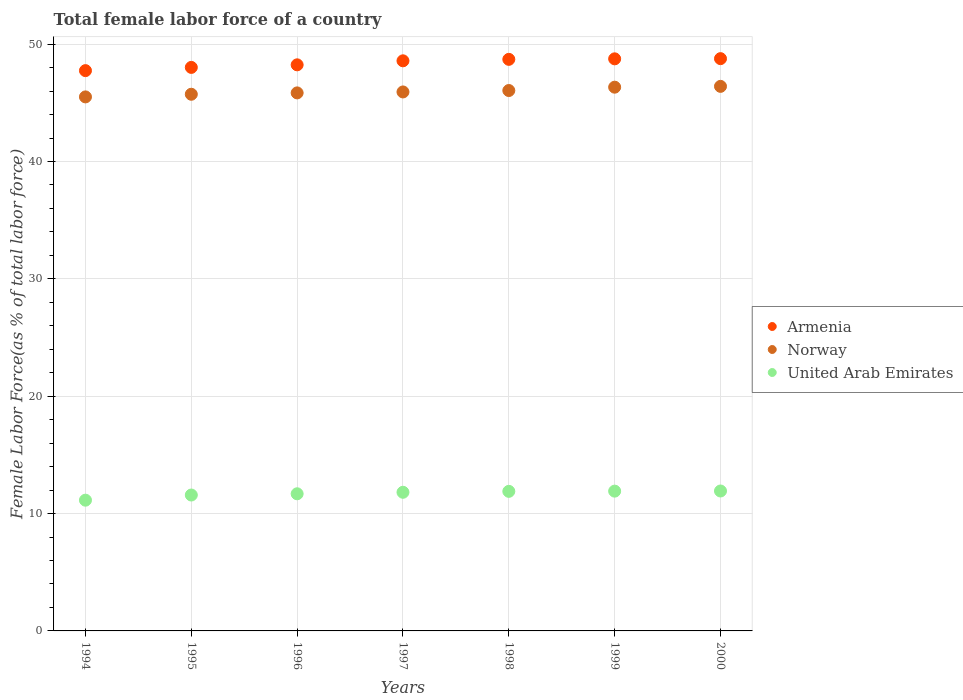How many different coloured dotlines are there?
Your answer should be very brief. 3. Is the number of dotlines equal to the number of legend labels?
Your response must be concise. Yes. What is the percentage of female labor force in Armenia in 1998?
Ensure brevity in your answer.  48.7. Across all years, what is the maximum percentage of female labor force in United Arab Emirates?
Your answer should be very brief. 11.92. Across all years, what is the minimum percentage of female labor force in United Arab Emirates?
Offer a terse response. 11.14. In which year was the percentage of female labor force in Norway maximum?
Provide a succinct answer. 2000. In which year was the percentage of female labor force in United Arab Emirates minimum?
Offer a terse response. 1994. What is the total percentage of female labor force in Armenia in the graph?
Ensure brevity in your answer.  338.8. What is the difference between the percentage of female labor force in Norway in 1996 and that in 1999?
Make the answer very short. -0.49. What is the difference between the percentage of female labor force in United Arab Emirates in 1998 and the percentage of female labor force in Armenia in 1996?
Your answer should be compact. -36.35. What is the average percentage of female labor force in United Arab Emirates per year?
Your answer should be compact. 11.71. In the year 1999, what is the difference between the percentage of female labor force in Armenia and percentage of female labor force in United Arab Emirates?
Give a very brief answer. 36.84. What is the ratio of the percentage of female labor force in Norway in 1995 to that in 1998?
Keep it short and to the point. 0.99. Is the difference between the percentage of female labor force in Armenia in 1998 and 1999 greater than the difference between the percentage of female labor force in United Arab Emirates in 1998 and 1999?
Ensure brevity in your answer.  No. What is the difference between the highest and the second highest percentage of female labor force in Norway?
Make the answer very short. 0.07. What is the difference between the highest and the lowest percentage of female labor force in United Arab Emirates?
Your answer should be very brief. 0.78. Is the percentage of female labor force in Norway strictly greater than the percentage of female labor force in Armenia over the years?
Provide a succinct answer. No. Is the percentage of female labor force in United Arab Emirates strictly less than the percentage of female labor force in Armenia over the years?
Offer a terse response. Yes. How many years are there in the graph?
Your response must be concise. 7. Are the values on the major ticks of Y-axis written in scientific E-notation?
Offer a terse response. No. How many legend labels are there?
Your answer should be compact. 3. What is the title of the graph?
Ensure brevity in your answer.  Total female labor force of a country. Does "Burkina Faso" appear as one of the legend labels in the graph?
Your answer should be very brief. No. What is the label or title of the X-axis?
Offer a very short reply. Years. What is the label or title of the Y-axis?
Ensure brevity in your answer.  Female Labor Force(as % of total labor force). What is the Female Labor Force(as % of total labor force) in Armenia in 1994?
Give a very brief answer. 47.74. What is the Female Labor Force(as % of total labor force) of Norway in 1994?
Your answer should be very brief. 45.5. What is the Female Labor Force(as % of total labor force) of United Arab Emirates in 1994?
Make the answer very short. 11.14. What is the Female Labor Force(as % of total labor force) in Armenia in 1995?
Ensure brevity in your answer.  48.02. What is the Female Labor Force(as % of total labor force) in Norway in 1995?
Give a very brief answer. 45.73. What is the Female Labor Force(as % of total labor force) in United Arab Emirates in 1995?
Provide a succinct answer. 11.58. What is the Female Labor Force(as % of total labor force) in Armenia in 1996?
Your response must be concise. 48.24. What is the Female Labor Force(as % of total labor force) of Norway in 1996?
Give a very brief answer. 45.85. What is the Female Labor Force(as % of total labor force) of United Arab Emirates in 1996?
Your response must be concise. 11.69. What is the Female Labor Force(as % of total labor force) in Armenia in 1997?
Give a very brief answer. 48.58. What is the Female Labor Force(as % of total labor force) in Norway in 1997?
Give a very brief answer. 45.93. What is the Female Labor Force(as % of total labor force) in United Arab Emirates in 1997?
Give a very brief answer. 11.81. What is the Female Labor Force(as % of total labor force) in Armenia in 1998?
Keep it short and to the point. 48.7. What is the Female Labor Force(as % of total labor force) in Norway in 1998?
Provide a short and direct response. 46.05. What is the Female Labor Force(as % of total labor force) in United Arab Emirates in 1998?
Offer a very short reply. 11.89. What is the Female Labor Force(as % of total labor force) of Armenia in 1999?
Give a very brief answer. 48.75. What is the Female Labor Force(as % of total labor force) of Norway in 1999?
Your response must be concise. 46.33. What is the Female Labor Force(as % of total labor force) in United Arab Emirates in 1999?
Your response must be concise. 11.91. What is the Female Labor Force(as % of total labor force) of Armenia in 2000?
Your answer should be compact. 48.76. What is the Female Labor Force(as % of total labor force) in Norway in 2000?
Your answer should be very brief. 46.4. What is the Female Labor Force(as % of total labor force) of United Arab Emirates in 2000?
Offer a terse response. 11.92. Across all years, what is the maximum Female Labor Force(as % of total labor force) in Armenia?
Keep it short and to the point. 48.76. Across all years, what is the maximum Female Labor Force(as % of total labor force) in Norway?
Keep it short and to the point. 46.4. Across all years, what is the maximum Female Labor Force(as % of total labor force) of United Arab Emirates?
Your answer should be compact. 11.92. Across all years, what is the minimum Female Labor Force(as % of total labor force) in Armenia?
Your response must be concise. 47.74. Across all years, what is the minimum Female Labor Force(as % of total labor force) in Norway?
Ensure brevity in your answer.  45.5. Across all years, what is the minimum Female Labor Force(as % of total labor force) of United Arab Emirates?
Your response must be concise. 11.14. What is the total Female Labor Force(as % of total labor force) of Armenia in the graph?
Keep it short and to the point. 338.8. What is the total Female Labor Force(as % of total labor force) of Norway in the graph?
Provide a short and direct response. 321.79. What is the total Female Labor Force(as % of total labor force) of United Arab Emirates in the graph?
Your answer should be very brief. 81.95. What is the difference between the Female Labor Force(as % of total labor force) in Armenia in 1994 and that in 1995?
Your response must be concise. -0.27. What is the difference between the Female Labor Force(as % of total labor force) in Norway in 1994 and that in 1995?
Make the answer very short. -0.23. What is the difference between the Female Labor Force(as % of total labor force) of United Arab Emirates in 1994 and that in 1995?
Give a very brief answer. -0.44. What is the difference between the Female Labor Force(as % of total labor force) of Armenia in 1994 and that in 1996?
Provide a succinct answer. -0.49. What is the difference between the Female Labor Force(as % of total labor force) of Norway in 1994 and that in 1996?
Offer a very short reply. -0.34. What is the difference between the Female Labor Force(as % of total labor force) in United Arab Emirates in 1994 and that in 1996?
Offer a very short reply. -0.55. What is the difference between the Female Labor Force(as % of total labor force) in Armenia in 1994 and that in 1997?
Keep it short and to the point. -0.84. What is the difference between the Female Labor Force(as % of total labor force) in Norway in 1994 and that in 1997?
Your answer should be very brief. -0.42. What is the difference between the Female Labor Force(as % of total labor force) of United Arab Emirates in 1994 and that in 1997?
Offer a terse response. -0.67. What is the difference between the Female Labor Force(as % of total labor force) in Armenia in 1994 and that in 1998?
Offer a terse response. -0.96. What is the difference between the Female Labor Force(as % of total labor force) in Norway in 1994 and that in 1998?
Keep it short and to the point. -0.54. What is the difference between the Female Labor Force(as % of total labor force) in United Arab Emirates in 1994 and that in 1998?
Provide a short and direct response. -0.75. What is the difference between the Female Labor Force(as % of total labor force) of Armenia in 1994 and that in 1999?
Your answer should be very brief. -1.01. What is the difference between the Female Labor Force(as % of total labor force) in Norway in 1994 and that in 1999?
Your response must be concise. -0.83. What is the difference between the Female Labor Force(as % of total labor force) in United Arab Emirates in 1994 and that in 1999?
Provide a short and direct response. -0.77. What is the difference between the Female Labor Force(as % of total labor force) of Armenia in 1994 and that in 2000?
Your answer should be compact. -1.02. What is the difference between the Female Labor Force(as % of total labor force) of Norway in 1994 and that in 2000?
Provide a succinct answer. -0.9. What is the difference between the Female Labor Force(as % of total labor force) in United Arab Emirates in 1994 and that in 2000?
Offer a very short reply. -0.78. What is the difference between the Female Labor Force(as % of total labor force) in Armenia in 1995 and that in 1996?
Your answer should be compact. -0.22. What is the difference between the Female Labor Force(as % of total labor force) in Norway in 1995 and that in 1996?
Provide a short and direct response. -0.12. What is the difference between the Female Labor Force(as % of total labor force) in United Arab Emirates in 1995 and that in 1996?
Your response must be concise. -0.11. What is the difference between the Female Labor Force(as % of total labor force) in Armenia in 1995 and that in 1997?
Give a very brief answer. -0.56. What is the difference between the Female Labor Force(as % of total labor force) of Norway in 1995 and that in 1997?
Your answer should be very brief. -0.2. What is the difference between the Female Labor Force(as % of total labor force) in United Arab Emirates in 1995 and that in 1997?
Give a very brief answer. -0.23. What is the difference between the Female Labor Force(as % of total labor force) of Armenia in 1995 and that in 1998?
Provide a succinct answer. -0.69. What is the difference between the Female Labor Force(as % of total labor force) in Norway in 1995 and that in 1998?
Your answer should be compact. -0.32. What is the difference between the Female Labor Force(as % of total labor force) in United Arab Emirates in 1995 and that in 1998?
Keep it short and to the point. -0.31. What is the difference between the Female Labor Force(as % of total labor force) of Armenia in 1995 and that in 1999?
Make the answer very short. -0.73. What is the difference between the Female Labor Force(as % of total labor force) of Norway in 1995 and that in 1999?
Ensure brevity in your answer.  -0.6. What is the difference between the Female Labor Force(as % of total labor force) of United Arab Emirates in 1995 and that in 1999?
Your answer should be compact. -0.33. What is the difference between the Female Labor Force(as % of total labor force) of Armenia in 1995 and that in 2000?
Make the answer very short. -0.75. What is the difference between the Female Labor Force(as % of total labor force) of Norway in 1995 and that in 2000?
Make the answer very short. -0.67. What is the difference between the Female Labor Force(as % of total labor force) in United Arab Emirates in 1995 and that in 2000?
Your answer should be compact. -0.34. What is the difference between the Female Labor Force(as % of total labor force) of Armenia in 1996 and that in 1997?
Keep it short and to the point. -0.34. What is the difference between the Female Labor Force(as % of total labor force) in Norway in 1996 and that in 1997?
Offer a terse response. -0.08. What is the difference between the Female Labor Force(as % of total labor force) in United Arab Emirates in 1996 and that in 1997?
Offer a very short reply. -0.13. What is the difference between the Female Labor Force(as % of total labor force) of Armenia in 1996 and that in 1998?
Offer a terse response. -0.47. What is the difference between the Female Labor Force(as % of total labor force) in Norway in 1996 and that in 1998?
Ensure brevity in your answer.  -0.2. What is the difference between the Female Labor Force(as % of total labor force) of United Arab Emirates in 1996 and that in 1998?
Make the answer very short. -0.21. What is the difference between the Female Labor Force(as % of total labor force) in Armenia in 1996 and that in 1999?
Your answer should be very brief. -0.51. What is the difference between the Female Labor Force(as % of total labor force) in Norway in 1996 and that in 1999?
Offer a very short reply. -0.49. What is the difference between the Female Labor Force(as % of total labor force) of United Arab Emirates in 1996 and that in 1999?
Provide a short and direct response. -0.23. What is the difference between the Female Labor Force(as % of total labor force) in Armenia in 1996 and that in 2000?
Provide a short and direct response. -0.53. What is the difference between the Female Labor Force(as % of total labor force) in Norway in 1996 and that in 2000?
Your answer should be very brief. -0.56. What is the difference between the Female Labor Force(as % of total labor force) in United Arab Emirates in 1996 and that in 2000?
Make the answer very short. -0.24. What is the difference between the Female Labor Force(as % of total labor force) of Armenia in 1997 and that in 1998?
Provide a short and direct response. -0.12. What is the difference between the Female Labor Force(as % of total labor force) of Norway in 1997 and that in 1998?
Your answer should be very brief. -0.12. What is the difference between the Female Labor Force(as % of total labor force) in United Arab Emirates in 1997 and that in 1998?
Your response must be concise. -0.08. What is the difference between the Female Labor Force(as % of total labor force) of Armenia in 1997 and that in 1999?
Offer a very short reply. -0.17. What is the difference between the Female Labor Force(as % of total labor force) in Norway in 1997 and that in 1999?
Offer a terse response. -0.41. What is the difference between the Female Labor Force(as % of total labor force) of United Arab Emirates in 1997 and that in 1999?
Provide a succinct answer. -0.1. What is the difference between the Female Labor Force(as % of total labor force) in Armenia in 1997 and that in 2000?
Your answer should be compact. -0.18. What is the difference between the Female Labor Force(as % of total labor force) of Norway in 1997 and that in 2000?
Your answer should be very brief. -0.48. What is the difference between the Female Labor Force(as % of total labor force) in United Arab Emirates in 1997 and that in 2000?
Offer a very short reply. -0.11. What is the difference between the Female Labor Force(as % of total labor force) of Armenia in 1998 and that in 1999?
Offer a terse response. -0.04. What is the difference between the Female Labor Force(as % of total labor force) of Norway in 1998 and that in 1999?
Provide a succinct answer. -0.28. What is the difference between the Female Labor Force(as % of total labor force) of United Arab Emirates in 1998 and that in 1999?
Ensure brevity in your answer.  -0.02. What is the difference between the Female Labor Force(as % of total labor force) of Armenia in 1998 and that in 2000?
Offer a very short reply. -0.06. What is the difference between the Female Labor Force(as % of total labor force) of Norway in 1998 and that in 2000?
Give a very brief answer. -0.35. What is the difference between the Female Labor Force(as % of total labor force) of United Arab Emirates in 1998 and that in 2000?
Provide a short and direct response. -0.03. What is the difference between the Female Labor Force(as % of total labor force) of Armenia in 1999 and that in 2000?
Keep it short and to the point. -0.02. What is the difference between the Female Labor Force(as % of total labor force) of Norway in 1999 and that in 2000?
Your answer should be very brief. -0.07. What is the difference between the Female Labor Force(as % of total labor force) of United Arab Emirates in 1999 and that in 2000?
Provide a succinct answer. -0.01. What is the difference between the Female Labor Force(as % of total labor force) in Armenia in 1994 and the Female Labor Force(as % of total labor force) in Norway in 1995?
Ensure brevity in your answer.  2.01. What is the difference between the Female Labor Force(as % of total labor force) in Armenia in 1994 and the Female Labor Force(as % of total labor force) in United Arab Emirates in 1995?
Make the answer very short. 36.16. What is the difference between the Female Labor Force(as % of total labor force) in Norway in 1994 and the Female Labor Force(as % of total labor force) in United Arab Emirates in 1995?
Ensure brevity in your answer.  33.92. What is the difference between the Female Labor Force(as % of total labor force) in Armenia in 1994 and the Female Labor Force(as % of total labor force) in Norway in 1996?
Keep it short and to the point. 1.9. What is the difference between the Female Labor Force(as % of total labor force) in Armenia in 1994 and the Female Labor Force(as % of total labor force) in United Arab Emirates in 1996?
Your answer should be very brief. 36.06. What is the difference between the Female Labor Force(as % of total labor force) of Norway in 1994 and the Female Labor Force(as % of total labor force) of United Arab Emirates in 1996?
Your answer should be compact. 33.82. What is the difference between the Female Labor Force(as % of total labor force) in Armenia in 1994 and the Female Labor Force(as % of total labor force) in Norway in 1997?
Ensure brevity in your answer.  1.82. What is the difference between the Female Labor Force(as % of total labor force) in Armenia in 1994 and the Female Labor Force(as % of total labor force) in United Arab Emirates in 1997?
Offer a terse response. 35.93. What is the difference between the Female Labor Force(as % of total labor force) in Norway in 1994 and the Female Labor Force(as % of total labor force) in United Arab Emirates in 1997?
Your answer should be very brief. 33.69. What is the difference between the Female Labor Force(as % of total labor force) of Armenia in 1994 and the Female Labor Force(as % of total labor force) of Norway in 1998?
Offer a terse response. 1.7. What is the difference between the Female Labor Force(as % of total labor force) of Armenia in 1994 and the Female Labor Force(as % of total labor force) of United Arab Emirates in 1998?
Provide a short and direct response. 35.85. What is the difference between the Female Labor Force(as % of total labor force) of Norway in 1994 and the Female Labor Force(as % of total labor force) of United Arab Emirates in 1998?
Make the answer very short. 33.61. What is the difference between the Female Labor Force(as % of total labor force) in Armenia in 1994 and the Female Labor Force(as % of total labor force) in Norway in 1999?
Your answer should be very brief. 1.41. What is the difference between the Female Labor Force(as % of total labor force) of Armenia in 1994 and the Female Labor Force(as % of total labor force) of United Arab Emirates in 1999?
Offer a very short reply. 35.83. What is the difference between the Female Labor Force(as % of total labor force) in Norway in 1994 and the Female Labor Force(as % of total labor force) in United Arab Emirates in 1999?
Your answer should be very brief. 33.59. What is the difference between the Female Labor Force(as % of total labor force) of Armenia in 1994 and the Female Labor Force(as % of total labor force) of Norway in 2000?
Give a very brief answer. 1.34. What is the difference between the Female Labor Force(as % of total labor force) in Armenia in 1994 and the Female Labor Force(as % of total labor force) in United Arab Emirates in 2000?
Offer a very short reply. 35.82. What is the difference between the Female Labor Force(as % of total labor force) in Norway in 1994 and the Female Labor Force(as % of total labor force) in United Arab Emirates in 2000?
Provide a short and direct response. 33.58. What is the difference between the Female Labor Force(as % of total labor force) in Armenia in 1995 and the Female Labor Force(as % of total labor force) in Norway in 1996?
Make the answer very short. 2.17. What is the difference between the Female Labor Force(as % of total labor force) of Armenia in 1995 and the Female Labor Force(as % of total labor force) of United Arab Emirates in 1996?
Ensure brevity in your answer.  36.33. What is the difference between the Female Labor Force(as % of total labor force) in Norway in 1995 and the Female Labor Force(as % of total labor force) in United Arab Emirates in 1996?
Make the answer very short. 34.04. What is the difference between the Female Labor Force(as % of total labor force) of Armenia in 1995 and the Female Labor Force(as % of total labor force) of Norway in 1997?
Your response must be concise. 2.09. What is the difference between the Female Labor Force(as % of total labor force) of Armenia in 1995 and the Female Labor Force(as % of total labor force) of United Arab Emirates in 1997?
Your answer should be compact. 36.2. What is the difference between the Female Labor Force(as % of total labor force) of Norway in 1995 and the Female Labor Force(as % of total labor force) of United Arab Emirates in 1997?
Offer a very short reply. 33.92. What is the difference between the Female Labor Force(as % of total labor force) in Armenia in 1995 and the Female Labor Force(as % of total labor force) in Norway in 1998?
Offer a very short reply. 1.97. What is the difference between the Female Labor Force(as % of total labor force) of Armenia in 1995 and the Female Labor Force(as % of total labor force) of United Arab Emirates in 1998?
Your response must be concise. 36.13. What is the difference between the Female Labor Force(as % of total labor force) of Norway in 1995 and the Female Labor Force(as % of total labor force) of United Arab Emirates in 1998?
Keep it short and to the point. 33.84. What is the difference between the Female Labor Force(as % of total labor force) of Armenia in 1995 and the Female Labor Force(as % of total labor force) of Norway in 1999?
Offer a terse response. 1.69. What is the difference between the Female Labor Force(as % of total labor force) in Armenia in 1995 and the Female Labor Force(as % of total labor force) in United Arab Emirates in 1999?
Offer a very short reply. 36.11. What is the difference between the Female Labor Force(as % of total labor force) in Norway in 1995 and the Female Labor Force(as % of total labor force) in United Arab Emirates in 1999?
Your answer should be very brief. 33.82. What is the difference between the Female Labor Force(as % of total labor force) in Armenia in 1995 and the Female Labor Force(as % of total labor force) in Norway in 2000?
Your answer should be very brief. 1.62. What is the difference between the Female Labor Force(as % of total labor force) of Armenia in 1995 and the Female Labor Force(as % of total labor force) of United Arab Emirates in 2000?
Your response must be concise. 36.1. What is the difference between the Female Labor Force(as % of total labor force) of Norway in 1995 and the Female Labor Force(as % of total labor force) of United Arab Emirates in 2000?
Your answer should be compact. 33.81. What is the difference between the Female Labor Force(as % of total labor force) of Armenia in 1996 and the Female Labor Force(as % of total labor force) of Norway in 1997?
Provide a short and direct response. 2.31. What is the difference between the Female Labor Force(as % of total labor force) in Armenia in 1996 and the Female Labor Force(as % of total labor force) in United Arab Emirates in 1997?
Keep it short and to the point. 36.42. What is the difference between the Female Labor Force(as % of total labor force) of Norway in 1996 and the Female Labor Force(as % of total labor force) of United Arab Emirates in 1997?
Give a very brief answer. 34.03. What is the difference between the Female Labor Force(as % of total labor force) in Armenia in 1996 and the Female Labor Force(as % of total labor force) in Norway in 1998?
Give a very brief answer. 2.19. What is the difference between the Female Labor Force(as % of total labor force) of Armenia in 1996 and the Female Labor Force(as % of total labor force) of United Arab Emirates in 1998?
Provide a short and direct response. 36.35. What is the difference between the Female Labor Force(as % of total labor force) of Norway in 1996 and the Female Labor Force(as % of total labor force) of United Arab Emirates in 1998?
Make the answer very short. 33.95. What is the difference between the Female Labor Force(as % of total labor force) of Armenia in 1996 and the Female Labor Force(as % of total labor force) of Norway in 1999?
Provide a succinct answer. 1.91. What is the difference between the Female Labor Force(as % of total labor force) of Armenia in 1996 and the Female Labor Force(as % of total labor force) of United Arab Emirates in 1999?
Your answer should be very brief. 36.33. What is the difference between the Female Labor Force(as % of total labor force) of Norway in 1996 and the Female Labor Force(as % of total labor force) of United Arab Emirates in 1999?
Make the answer very short. 33.94. What is the difference between the Female Labor Force(as % of total labor force) of Armenia in 1996 and the Female Labor Force(as % of total labor force) of Norway in 2000?
Your response must be concise. 1.84. What is the difference between the Female Labor Force(as % of total labor force) in Armenia in 1996 and the Female Labor Force(as % of total labor force) in United Arab Emirates in 2000?
Provide a succinct answer. 36.31. What is the difference between the Female Labor Force(as % of total labor force) of Norway in 1996 and the Female Labor Force(as % of total labor force) of United Arab Emirates in 2000?
Provide a succinct answer. 33.92. What is the difference between the Female Labor Force(as % of total labor force) of Armenia in 1997 and the Female Labor Force(as % of total labor force) of Norway in 1998?
Your response must be concise. 2.53. What is the difference between the Female Labor Force(as % of total labor force) of Armenia in 1997 and the Female Labor Force(as % of total labor force) of United Arab Emirates in 1998?
Give a very brief answer. 36.69. What is the difference between the Female Labor Force(as % of total labor force) in Norway in 1997 and the Female Labor Force(as % of total labor force) in United Arab Emirates in 1998?
Ensure brevity in your answer.  34.03. What is the difference between the Female Labor Force(as % of total labor force) in Armenia in 1997 and the Female Labor Force(as % of total labor force) in Norway in 1999?
Your answer should be very brief. 2.25. What is the difference between the Female Labor Force(as % of total labor force) in Armenia in 1997 and the Female Labor Force(as % of total labor force) in United Arab Emirates in 1999?
Provide a short and direct response. 36.67. What is the difference between the Female Labor Force(as % of total labor force) of Norway in 1997 and the Female Labor Force(as % of total labor force) of United Arab Emirates in 1999?
Provide a short and direct response. 34.02. What is the difference between the Female Labor Force(as % of total labor force) of Armenia in 1997 and the Female Labor Force(as % of total labor force) of Norway in 2000?
Provide a succinct answer. 2.18. What is the difference between the Female Labor Force(as % of total labor force) in Armenia in 1997 and the Female Labor Force(as % of total labor force) in United Arab Emirates in 2000?
Offer a very short reply. 36.66. What is the difference between the Female Labor Force(as % of total labor force) in Norway in 1997 and the Female Labor Force(as % of total labor force) in United Arab Emirates in 2000?
Make the answer very short. 34. What is the difference between the Female Labor Force(as % of total labor force) in Armenia in 1998 and the Female Labor Force(as % of total labor force) in Norway in 1999?
Make the answer very short. 2.37. What is the difference between the Female Labor Force(as % of total labor force) in Armenia in 1998 and the Female Labor Force(as % of total labor force) in United Arab Emirates in 1999?
Your answer should be compact. 36.79. What is the difference between the Female Labor Force(as % of total labor force) in Norway in 1998 and the Female Labor Force(as % of total labor force) in United Arab Emirates in 1999?
Keep it short and to the point. 34.14. What is the difference between the Female Labor Force(as % of total labor force) in Armenia in 1998 and the Female Labor Force(as % of total labor force) in Norway in 2000?
Provide a short and direct response. 2.3. What is the difference between the Female Labor Force(as % of total labor force) of Armenia in 1998 and the Female Labor Force(as % of total labor force) of United Arab Emirates in 2000?
Make the answer very short. 36.78. What is the difference between the Female Labor Force(as % of total labor force) in Norway in 1998 and the Female Labor Force(as % of total labor force) in United Arab Emirates in 2000?
Your answer should be very brief. 34.13. What is the difference between the Female Labor Force(as % of total labor force) of Armenia in 1999 and the Female Labor Force(as % of total labor force) of Norway in 2000?
Your answer should be compact. 2.35. What is the difference between the Female Labor Force(as % of total labor force) in Armenia in 1999 and the Female Labor Force(as % of total labor force) in United Arab Emirates in 2000?
Offer a terse response. 36.83. What is the difference between the Female Labor Force(as % of total labor force) in Norway in 1999 and the Female Labor Force(as % of total labor force) in United Arab Emirates in 2000?
Give a very brief answer. 34.41. What is the average Female Labor Force(as % of total labor force) in Armenia per year?
Your answer should be very brief. 48.4. What is the average Female Labor Force(as % of total labor force) in Norway per year?
Your answer should be compact. 45.97. What is the average Female Labor Force(as % of total labor force) of United Arab Emirates per year?
Your response must be concise. 11.71. In the year 1994, what is the difference between the Female Labor Force(as % of total labor force) in Armenia and Female Labor Force(as % of total labor force) in Norway?
Your response must be concise. 2.24. In the year 1994, what is the difference between the Female Labor Force(as % of total labor force) in Armenia and Female Labor Force(as % of total labor force) in United Arab Emirates?
Give a very brief answer. 36.6. In the year 1994, what is the difference between the Female Labor Force(as % of total labor force) in Norway and Female Labor Force(as % of total labor force) in United Arab Emirates?
Make the answer very short. 34.36. In the year 1995, what is the difference between the Female Labor Force(as % of total labor force) of Armenia and Female Labor Force(as % of total labor force) of Norway?
Offer a very short reply. 2.29. In the year 1995, what is the difference between the Female Labor Force(as % of total labor force) of Armenia and Female Labor Force(as % of total labor force) of United Arab Emirates?
Keep it short and to the point. 36.44. In the year 1995, what is the difference between the Female Labor Force(as % of total labor force) in Norway and Female Labor Force(as % of total labor force) in United Arab Emirates?
Make the answer very short. 34.15. In the year 1996, what is the difference between the Female Labor Force(as % of total labor force) in Armenia and Female Labor Force(as % of total labor force) in Norway?
Your answer should be very brief. 2.39. In the year 1996, what is the difference between the Female Labor Force(as % of total labor force) of Armenia and Female Labor Force(as % of total labor force) of United Arab Emirates?
Your answer should be compact. 36.55. In the year 1996, what is the difference between the Female Labor Force(as % of total labor force) of Norway and Female Labor Force(as % of total labor force) of United Arab Emirates?
Ensure brevity in your answer.  34.16. In the year 1997, what is the difference between the Female Labor Force(as % of total labor force) in Armenia and Female Labor Force(as % of total labor force) in Norway?
Your answer should be compact. 2.65. In the year 1997, what is the difference between the Female Labor Force(as % of total labor force) of Armenia and Female Labor Force(as % of total labor force) of United Arab Emirates?
Provide a succinct answer. 36.77. In the year 1997, what is the difference between the Female Labor Force(as % of total labor force) of Norway and Female Labor Force(as % of total labor force) of United Arab Emirates?
Offer a very short reply. 34.11. In the year 1998, what is the difference between the Female Labor Force(as % of total labor force) in Armenia and Female Labor Force(as % of total labor force) in Norway?
Your response must be concise. 2.66. In the year 1998, what is the difference between the Female Labor Force(as % of total labor force) in Armenia and Female Labor Force(as % of total labor force) in United Arab Emirates?
Keep it short and to the point. 36.81. In the year 1998, what is the difference between the Female Labor Force(as % of total labor force) in Norway and Female Labor Force(as % of total labor force) in United Arab Emirates?
Offer a terse response. 34.16. In the year 1999, what is the difference between the Female Labor Force(as % of total labor force) in Armenia and Female Labor Force(as % of total labor force) in Norway?
Provide a succinct answer. 2.42. In the year 1999, what is the difference between the Female Labor Force(as % of total labor force) in Armenia and Female Labor Force(as % of total labor force) in United Arab Emirates?
Your answer should be very brief. 36.84. In the year 1999, what is the difference between the Female Labor Force(as % of total labor force) in Norway and Female Labor Force(as % of total labor force) in United Arab Emirates?
Provide a succinct answer. 34.42. In the year 2000, what is the difference between the Female Labor Force(as % of total labor force) in Armenia and Female Labor Force(as % of total labor force) in Norway?
Your answer should be very brief. 2.36. In the year 2000, what is the difference between the Female Labor Force(as % of total labor force) in Armenia and Female Labor Force(as % of total labor force) in United Arab Emirates?
Offer a very short reply. 36.84. In the year 2000, what is the difference between the Female Labor Force(as % of total labor force) of Norway and Female Labor Force(as % of total labor force) of United Arab Emirates?
Give a very brief answer. 34.48. What is the ratio of the Female Labor Force(as % of total labor force) in United Arab Emirates in 1994 to that in 1995?
Give a very brief answer. 0.96. What is the ratio of the Female Labor Force(as % of total labor force) of Armenia in 1994 to that in 1996?
Offer a very short reply. 0.99. What is the ratio of the Female Labor Force(as % of total labor force) in United Arab Emirates in 1994 to that in 1996?
Your answer should be compact. 0.95. What is the ratio of the Female Labor Force(as % of total labor force) in Armenia in 1994 to that in 1997?
Your response must be concise. 0.98. What is the ratio of the Female Labor Force(as % of total labor force) of United Arab Emirates in 1994 to that in 1997?
Offer a terse response. 0.94. What is the ratio of the Female Labor Force(as % of total labor force) of Armenia in 1994 to that in 1998?
Ensure brevity in your answer.  0.98. What is the ratio of the Female Labor Force(as % of total labor force) of United Arab Emirates in 1994 to that in 1998?
Ensure brevity in your answer.  0.94. What is the ratio of the Female Labor Force(as % of total labor force) of Armenia in 1994 to that in 1999?
Your response must be concise. 0.98. What is the ratio of the Female Labor Force(as % of total labor force) of Norway in 1994 to that in 1999?
Your response must be concise. 0.98. What is the ratio of the Female Labor Force(as % of total labor force) of United Arab Emirates in 1994 to that in 1999?
Offer a very short reply. 0.94. What is the ratio of the Female Labor Force(as % of total labor force) of Armenia in 1994 to that in 2000?
Offer a terse response. 0.98. What is the ratio of the Female Labor Force(as % of total labor force) in Norway in 1994 to that in 2000?
Offer a very short reply. 0.98. What is the ratio of the Female Labor Force(as % of total labor force) in United Arab Emirates in 1994 to that in 2000?
Give a very brief answer. 0.93. What is the ratio of the Female Labor Force(as % of total labor force) in United Arab Emirates in 1995 to that in 1996?
Provide a succinct answer. 0.99. What is the ratio of the Female Labor Force(as % of total labor force) of Armenia in 1995 to that in 1997?
Offer a very short reply. 0.99. What is the ratio of the Female Labor Force(as % of total labor force) in Norway in 1995 to that in 1997?
Provide a short and direct response. 1. What is the ratio of the Female Labor Force(as % of total labor force) of United Arab Emirates in 1995 to that in 1997?
Provide a succinct answer. 0.98. What is the ratio of the Female Labor Force(as % of total labor force) of Armenia in 1995 to that in 1998?
Your response must be concise. 0.99. What is the ratio of the Female Labor Force(as % of total labor force) in Norway in 1995 to that in 1998?
Offer a very short reply. 0.99. What is the ratio of the Female Labor Force(as % of total labor force) of United Arab Emirates in 1995 to that in 1998?
Keep it short and to the point. 0.97. What is the ratio of the Female Labor Force(as % of total labor force) in United Arab Emirates in 1995 to that in 1999?
Your answer should be very brief. 0.97. What is the ratio of the Female Labor Force(as % of total labor force) in Armenia in 1995 to that in 2000?
Keep it short and to the point. 0.98. What is the ratio of the Female Labor Force(as % of total labor force) in Norway in 1995 to that in 2000?
Your answer should be compact. 0.99. What is the ratio of the Female Labor Force(as % of total labor force) in United Arab Emirates in 1995 to that in 2000?
Provide a succinct answer. 0.97. What is the ratio of the Female Labor Force(as % of total labor force) in Norway in 1996 to that in 1997?
Make the answer very short. 1. What is the ratio of the Female Labor Force(as % of total labor force) of United Arab Emirates in 1996 to that in 1997?
Keep it short and to the point. 0.99. What is the ratio of the Female Labor Force(as % of total labor force) in Armenia in 1996 to that in 1998?
Offer a very short reply. 0.99. What is the ratio of the Female Labor Force(as % of total labor force) of Norway in 1996 to that in 1998?
Make the answer very short. 1. What is the ratio of the Female Labor Force(as % of total labor force) in United Arab Emirates in 1996 to that in 1998?
Your response must be concise. 0.98. What is the ratio of the Female Labor Force(as % of total labor force) in Armenia in 1996 to that in 1999?
Offer a terse response. 0.99. What is the ratio of the Female Labor Force(as % of total labor force) in Norway in 1996 to that in 1999?
Ensure brevity in your answer.  0.99. What is the ratio of the Female Labor Force(as % of total labor force) of United Arab Emirates in 1996 to that in 1999?
Your answer should be very brief. 0.98. What is the ratio of the Female Labor Force(as % of total labor force) in Armenia in 1996 to that in 2000?
Provide a succinct answer. 0.99. What is the ratio of the Female Labor Force(as % of total labor force) of United Arab Emirates in 1996 to that in 2000?
Your response must be concise. 0.98. What is the ratio of the Female Labor Force(as % of total labor force) in Norway in 1997 to that in 1998?
Offer a very short reply. 1. What is the ratio of the Female Labor Force(as % of total labor force) of Norway in 1997 to that in 1999?
Offer a terse response. 0.99. What is the ratio of the Female Labor Force(as % of total labor force) in United Arab Emirates in 1997 to that in 2000?
Provide a succinct answer. 0.99. What is the ratio of the Female Labor Force(as % of total labor force) of Armenia in 1998 to that in 1999?
Offer a terse response. 1. What is the ratio of the Female Labor Force(as % of total labor force) in Armenia in 1998 to that in 2000?
Your response must be concise. 1. What is the ratio of the Female Labor Force(as % of total labor force) in United Arab Emirates in 1998 to that in 2000?
Your answer should be compact. 1. What is the ratio of the Female Labor Force(as % of total labor force) in Norway in 1999 to that in 2000?
Make the answer very short. 1. What is the difference between the highest and the second highest Female Labor Force(as % of total labor force) in Armenia?
Offer a terse response. 0.02. What is the difference between the highest and the second highest Female Labor Force(as % of total labor force) of Norway?
Offer a terse response. 0.07. What is the difference between the highest and the second highest Female Labor Force(as % of total labor force) of United Arab Emirates?
Offer a terse response. 0.01. What is the difference between the highest and the lowest Female Labor Force(as % of total labor force) of Armenia?
Offer a terse response. 1.02. What is the difference between the highest and the lowest Female Labor Force(as % of total labor force) of Norway?
Your answer should be compact. 0.9. What is the difference between the highest and the lowest Female Labor Force(as % of total labor force) in United Arab Emirates?
Offer a terse response. 0.78. 